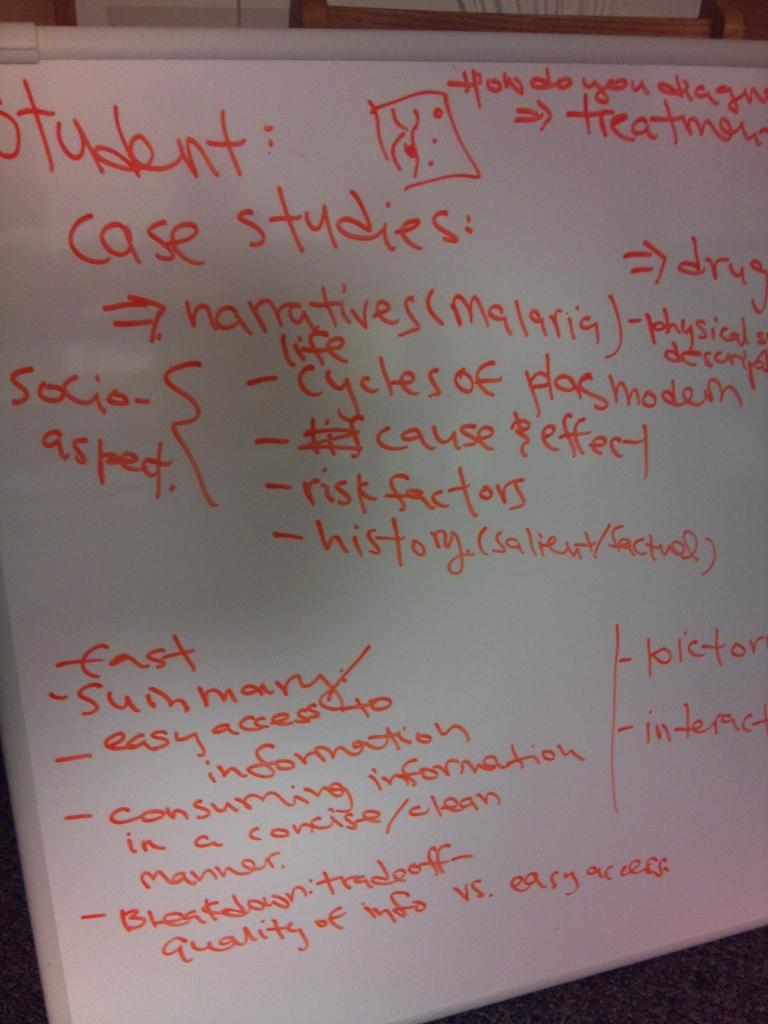What is the main object in the image? There is a whiteboard in the image. What is written or drawn on the whiteboard? There is text on the whiteboard. How many bees can be seen flying around the whiteboard in the image? There are no bees present in the image; it only features a whiteboard with text. 